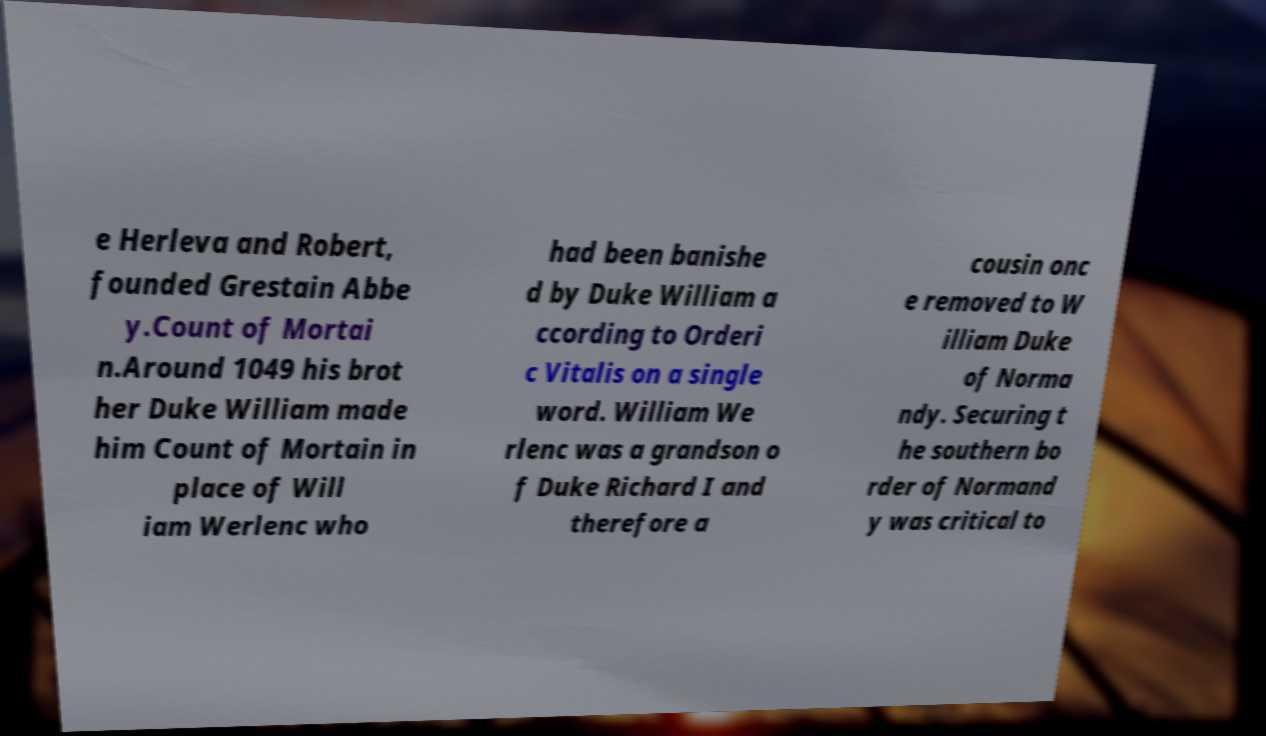Please read and relay the text visible in this image. What does it say? e Herleva and Robert, founded Grestain Abbe y.Count of Mortai n.Around 1049 his brot her Duke William made him Count of Mortain in place of Will iam Werlenc who had been banishe d by Duke William a ccording to Orderi c Vitalis on a single word. William We rlenc was a grandson o f Duke Richard I and therefore a cousin onc e removed to W illiam Duke of Norma ndy. Securing t he southern bo rder of Normand y was critical to 